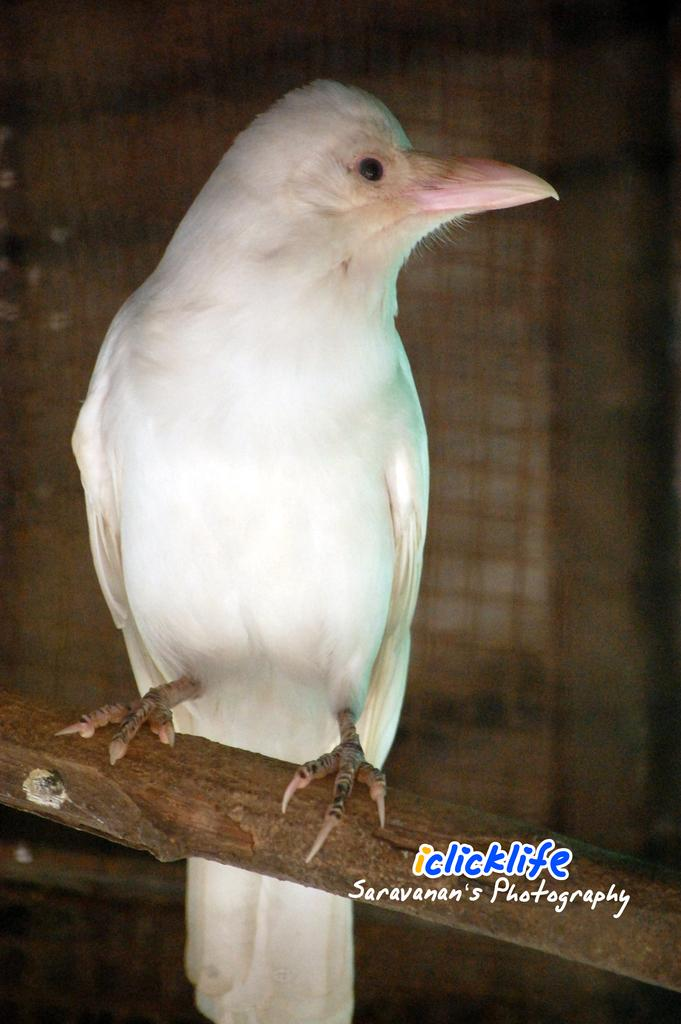What is the main subject in the foreground of the image? There is a bird in the foreground of the image. What is the bird perched on? The bird is on a bamboo. What can be found at the bottom of the image? There is text at the bottom of the image. What might be used for catching or holding objects in the background of the image? It appears there is a net in the background of the image. How many bells are hanging from the bird's neck in the image? There are no bells hanging from the bird's neck in the image. What type of jar is visible on the bamboo next to the bird? There is no jar present in the image; it features a bird on a bamboo with text at the bottom and a net in the background. 